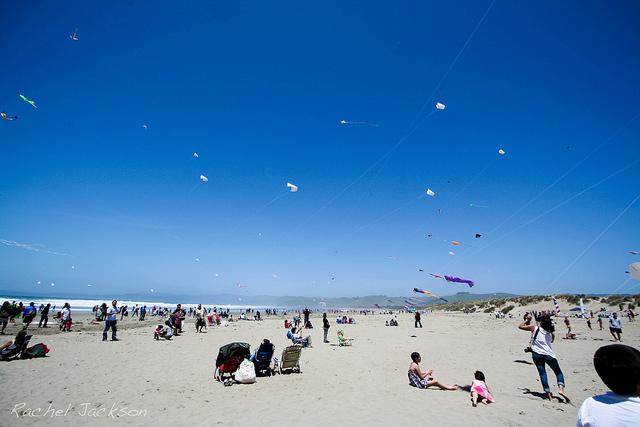What keeps the kites in the air?
Quick response, please. Wind. Why people are flying kites?
Concise answer only. Fun. Is this a tropical climate?
Concise answer only. Yes. Are there people lying in the sand?
Concise answer only. Yes. 